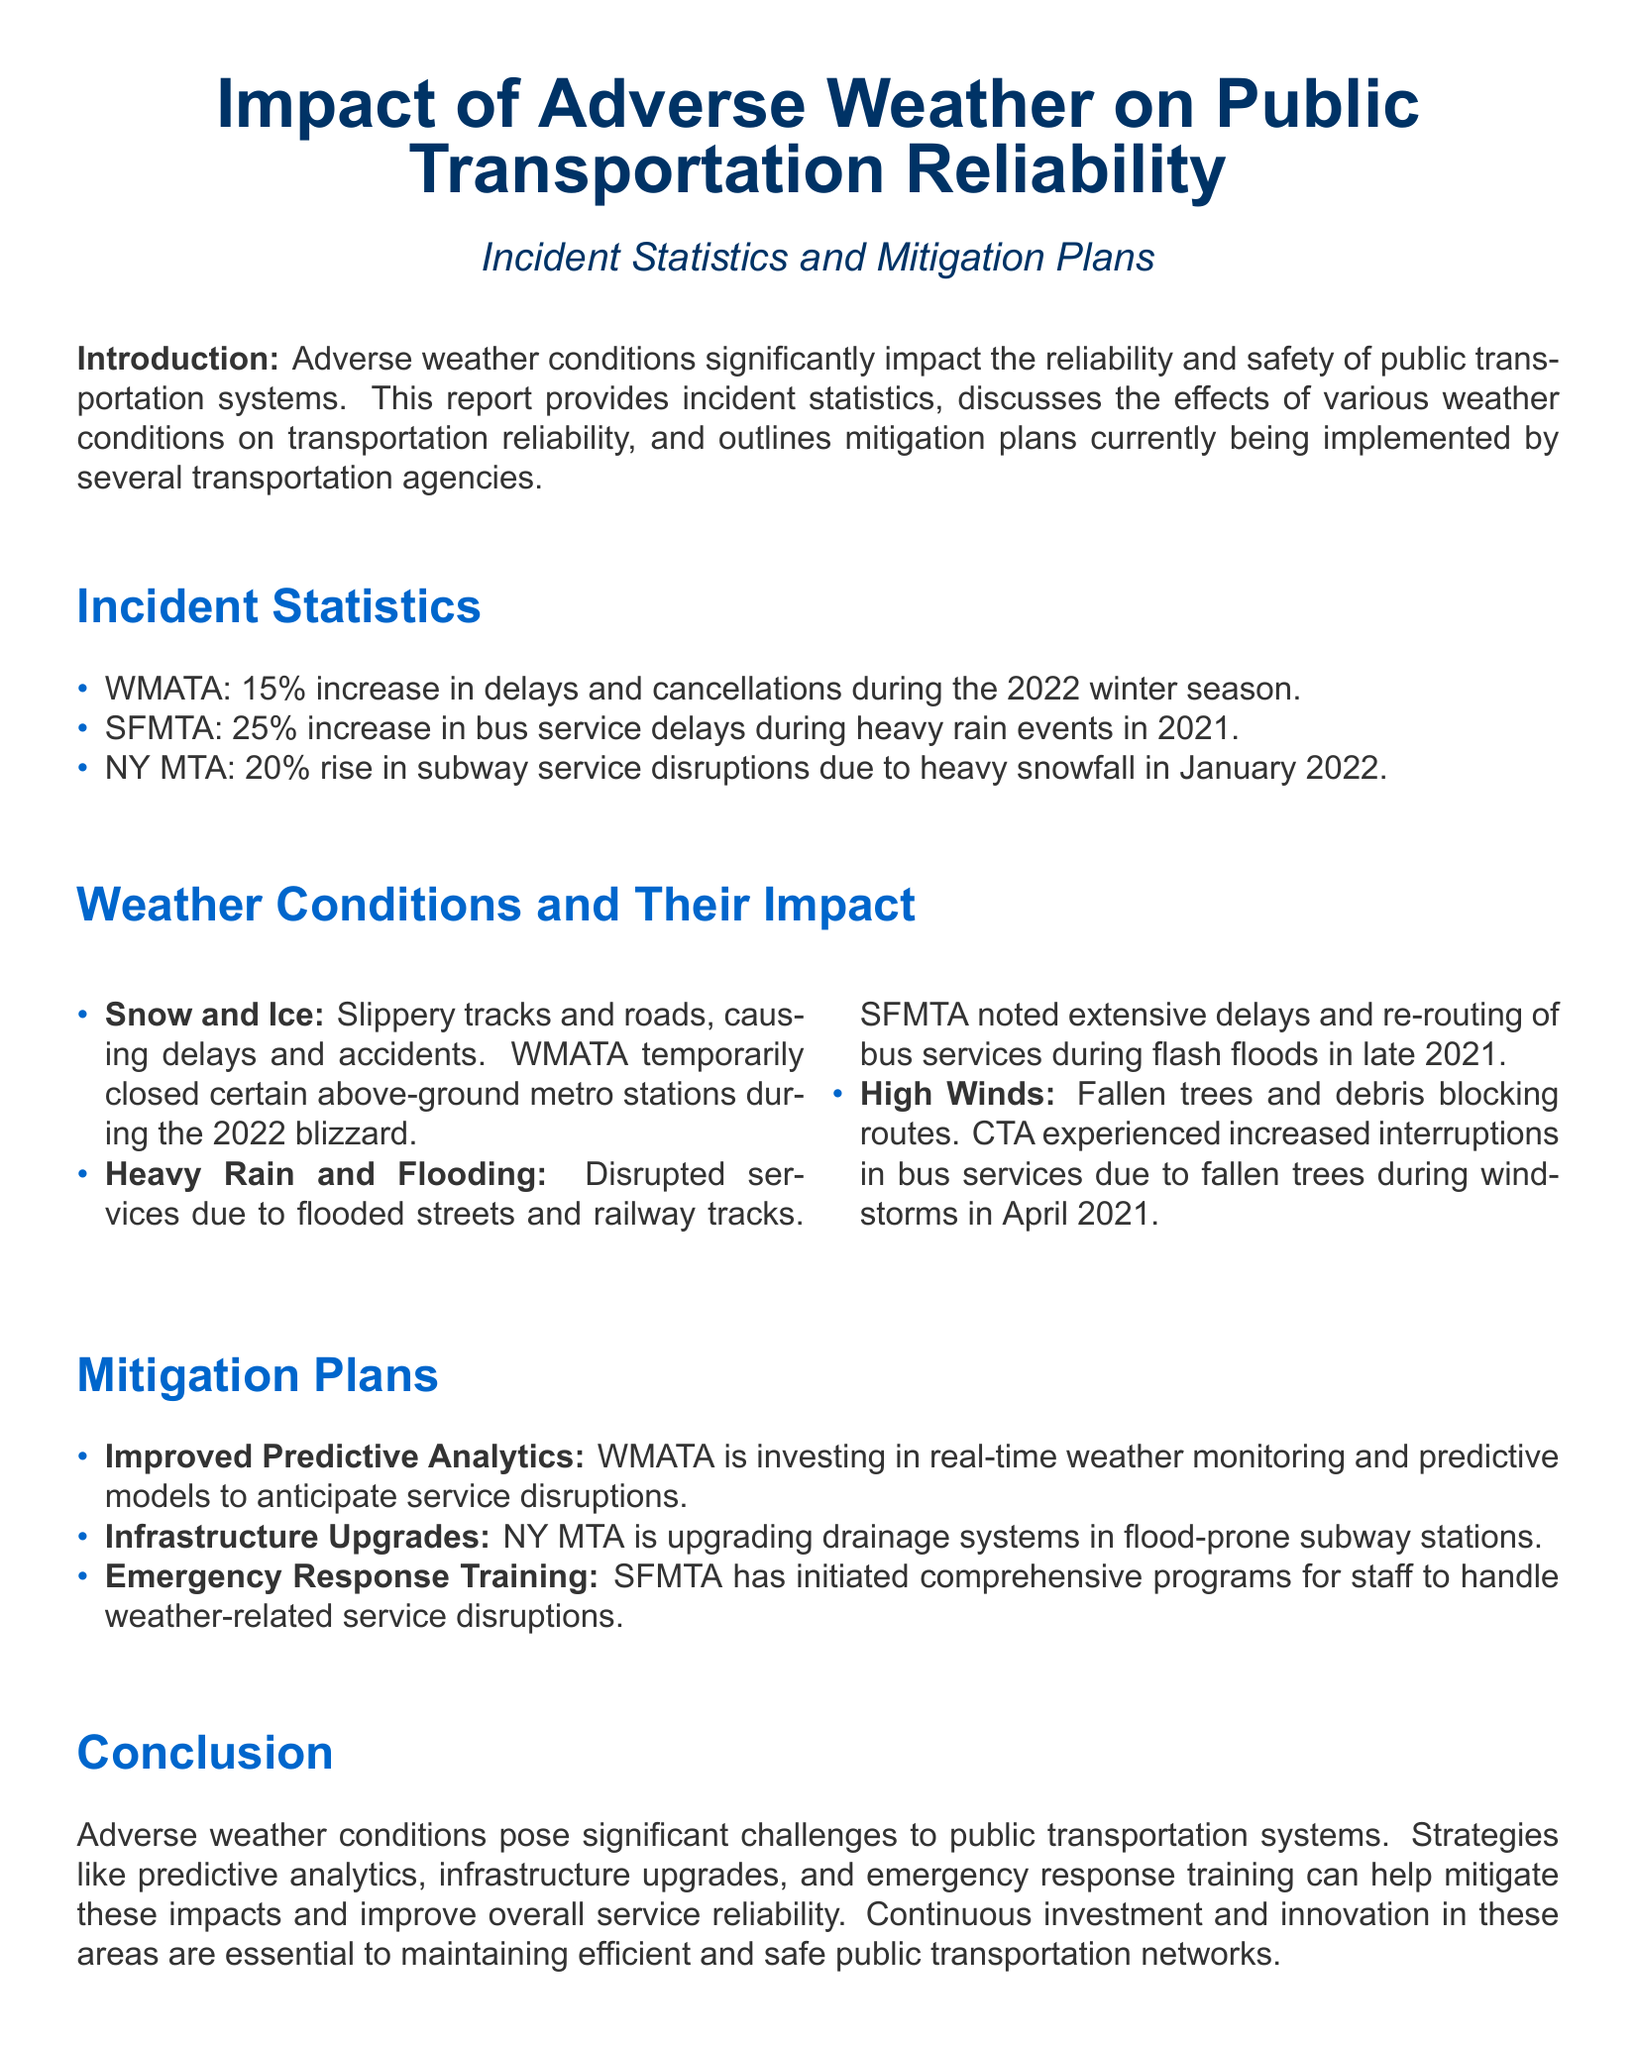what was the WMATA delay increase percentage during winter 2022? The WMATA reported a 15% increase in delays and cancellations during the 2022 winter season.
Answer: 15% what weather condition caused a rise in subway disruptions for NY MTA in January 2022? The NY MTA experienced a 20% rise in subway service disruptions due to heavy snowfall in January 2022.
Answer: heavy snowfall what mitigation plan involves real-time weather monitoring? WMATA is investing in improved predictive analytics for real-time weather monitoring to anticipate service disruptions.
Answer: improved predictive analytics how did heavy rain affect SFMTA services in 2021? The SFMTA noted a 25% increase in bus service delays during heavy rain events in 2021.
Answer: 25% increase which transportation agency upgraded drainage systems? The NY MTA is upgrading drainage systems in flood-prone subway stations.
Answer: NY MTA what specific adverse weather impact did high winds have on CTA services? High winds caused fallen trees and debris that blocked routes, leading to increased interruptions in bus services.
Answer: increased interruptions what is one mitigation plan for emergency situations by SFMTA? SFMTA has initiated comprehensive programs for staff to handle weather-related service disruptions through emergency response training.
Answer: emergency response training what is the primary concern discussed in the introduction of the report? The introduction highlights the significant impact of adverse weather conditions on the reliability and safety of public transportation systems.
Answer: reliability and safety 